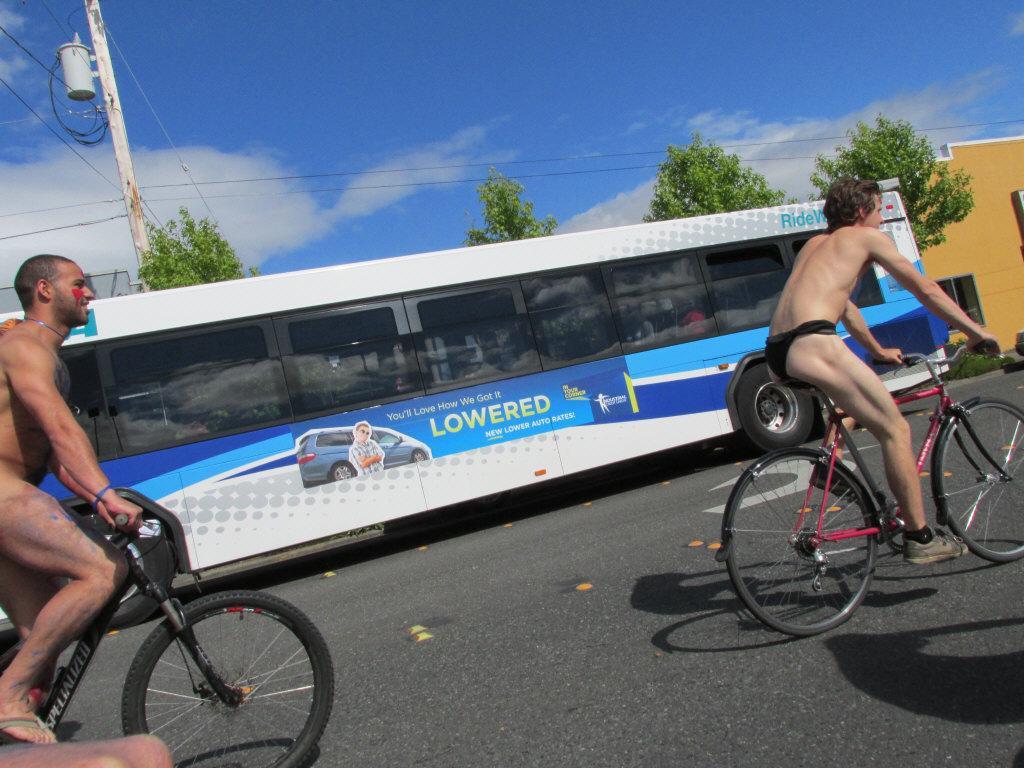Describe this image in one or two sentences. The image is taken on a road, there are two cycles two men are riding the cycles,behind them there is a bus, in the background that is the sky,a pole some trees and clouds. 